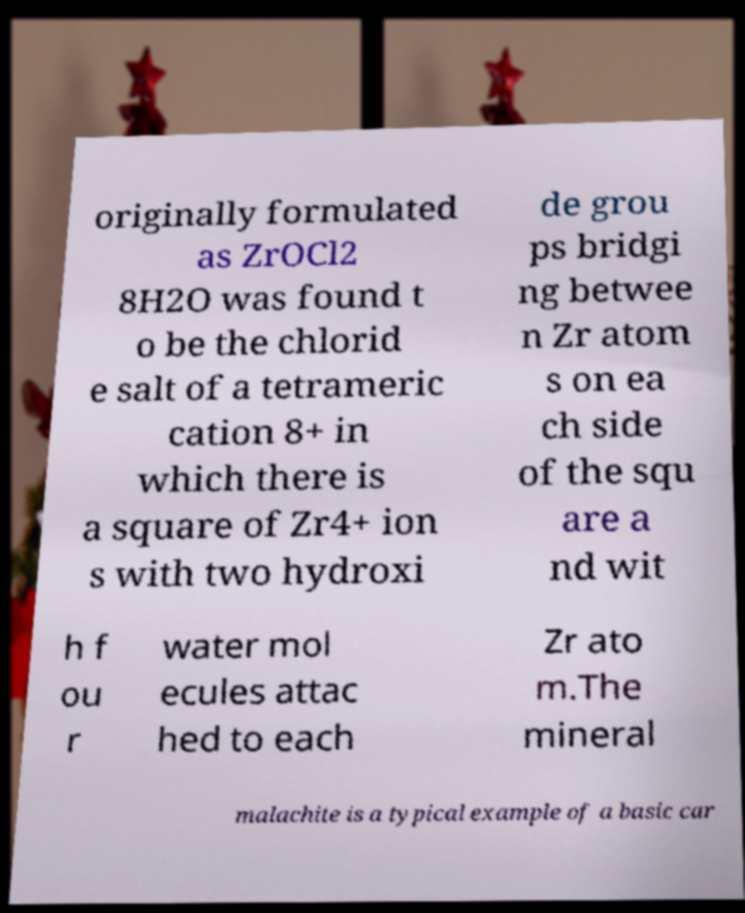What messages or text are displayed in this image? I need them in a readable, typed format. originally formulated as ZrOCl2 8H2O was found t o be the chlorid e salt of a tetrameric cation 8+ in which there is a square of Zr4+ ion s with two hydroxi de grou ps bridgi ng betwee n Zr atom s on ea ch side of the squ are a nd wit h f ou r water mol ecules attac hed to each Zr ato m.The mineral malachite is a typical example of a basic car 